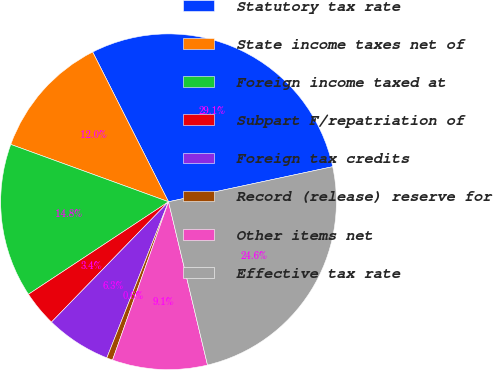Convert chart to OTSL. <chart><loc_0><loc_0><loc_500><loc_500><pie_chart><fcel>Statutory tax rate<fcel>State income taxes net of<fcel>Foreign income taxed at<fcel>Subpart F/repatriation of<fcel>Foreign tax credits<fcel>Record (release) reserve for<fcel>Other items net<fcel>Effective tax rate<nl><fcel>29.11%<fcel>11.99%<fcel>14.84%<fcel>3.43%<fcel>6.29%<fcel>0.58%<fcel>9.14%<fcel>24.62%<nl></chart> 